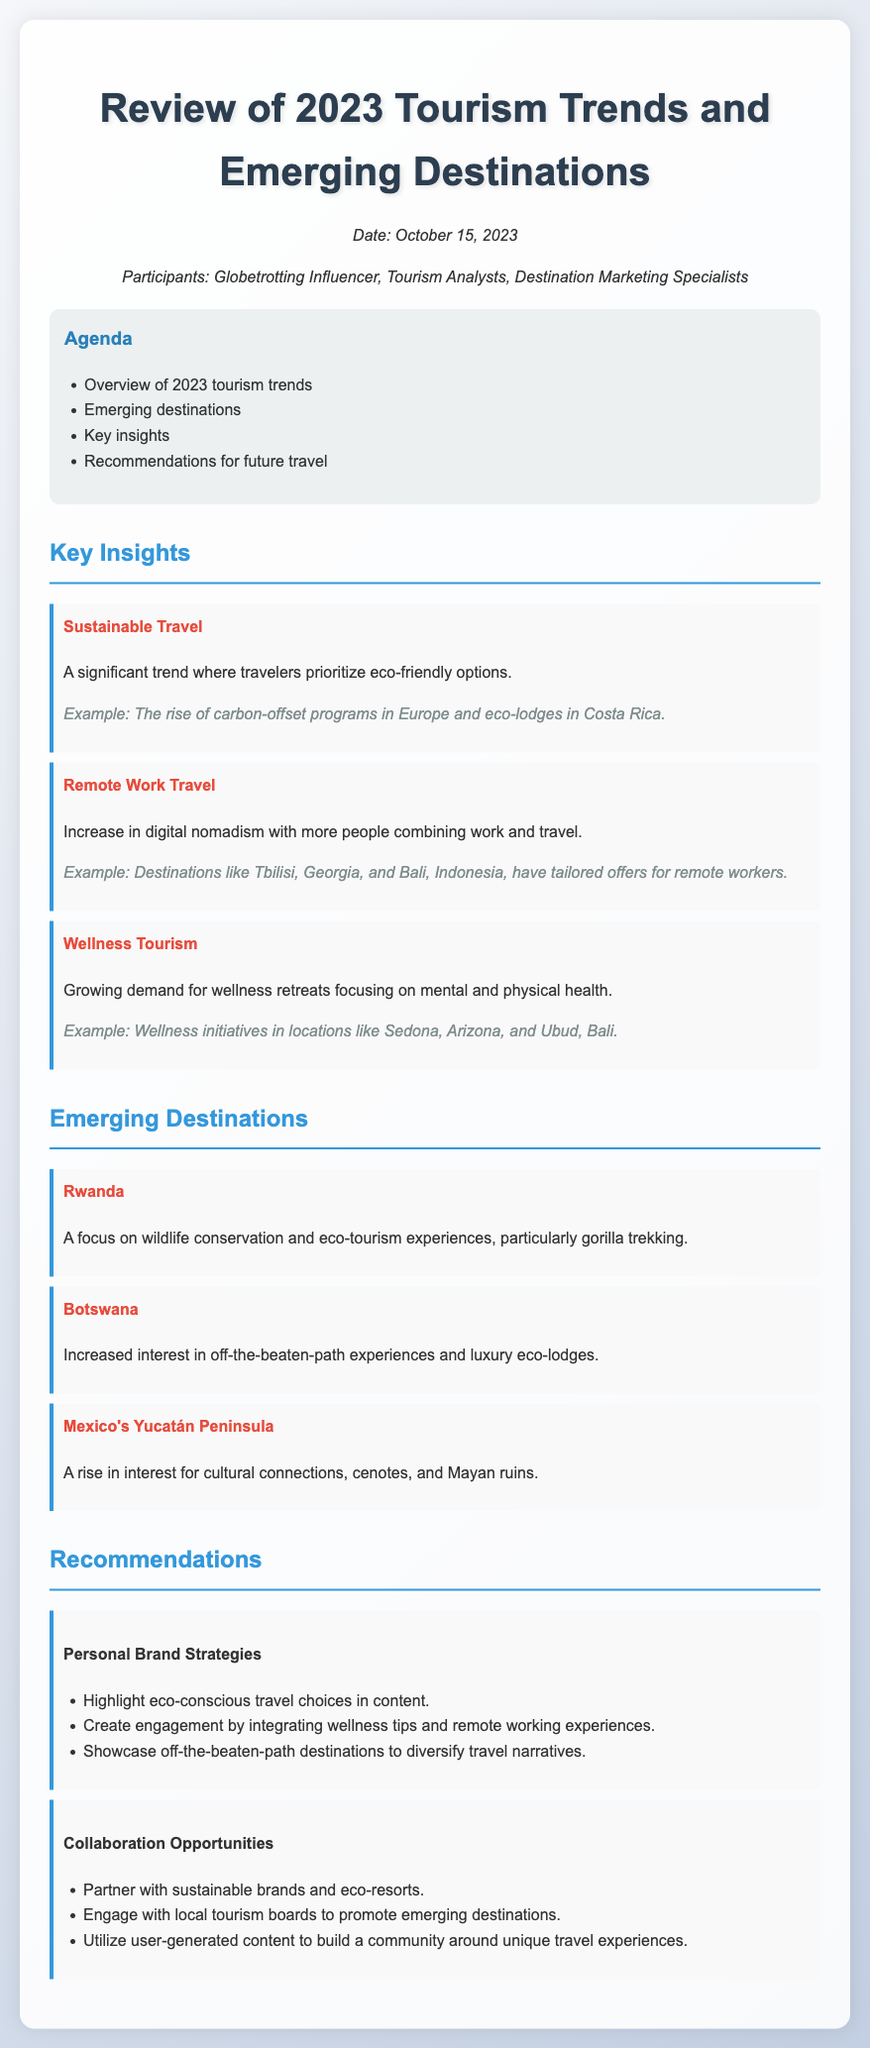What is the date of the meeting? The date of the meeting is explicitly stated in the document.
Answer: October 15, 2023 Who are the participants in the meeting? The participants are listed in the document, summarizing who attended the meeting.
Answer: Globetrotting Influencer, Tourism Analysts, Destination Marketing Specialists What type of tourism is highlighted under key insights? The document lists the main insights, including specific types of tourism trends.
Answer: Sustainable Travel Which emerging destination focuses on wildlife conservation? The document specifies emerging destinations, giving details about unique offerings.
Answer: Rwanda What is a recommendation related to personal brand strategies? The document outlines specific recommendations, focusing on branding in tourism.
Answer: Highlight eco-conscious travel choices in content Name one destination known for wellness initiatives. The document provides examples of destinations associated with wellness tourism.
Answer: Sedona, Arizona What trend is associated with digital nomadism? The document discusses travel trends, specifically in relation to work and travel.
Answer: Remote Work Travel Which region has seen increased interest for cultural connections? The document specifies emerging destinations linked to cultural experiences.
Answer: Mexico's Yucatán Peninsula What type of opportunities are recommended for collaborations? The recommendations suggest various engagement avenues for influencers in tourism.
Answer: Partner with sustainable brands and eco-resorts 